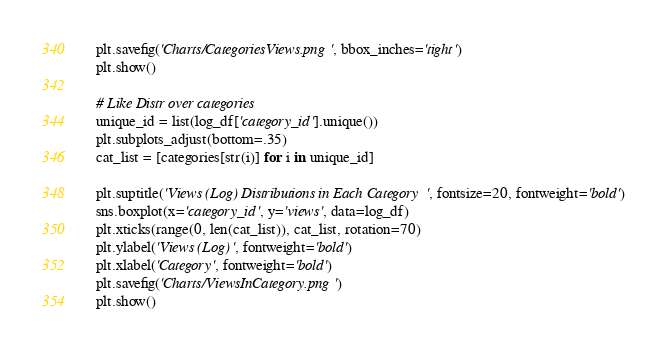Convert code to text. <code><loc_0><loc_0><loc_500><loc_500><_Python_>    plt.savefig('Charts/CategoriesViews.png', bbox_inches='tight')
    plt.show()

    # Like Distr over categories
    unique_id = list(log_df['category_id'].unique())
    plt.subplots_adjust(bottom=.35)
    cat_list = [categories[str(i)] for i in unique_id]

    plt.suptitle('Views (Log) Distributions in Each Category', fontsize=20, fontweight='bold')
    sns.boxplot(x='category_id', y='views', data=log_df)
    plt.xticks(range(0, len(cat_list)), cat_list, rotation=70)
    plt.ylabel('Views (Log)', fontweight='bold')
    plt.xlabel('Category', fontweight='bold')
    plt.savefig('Charts/ViewsInCategory.png')
    plt.show()
</code> 